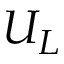Convert formula to latex. <formula><loc_0><loc_0><loc_500><loc_500>U _ { L }</formula> 